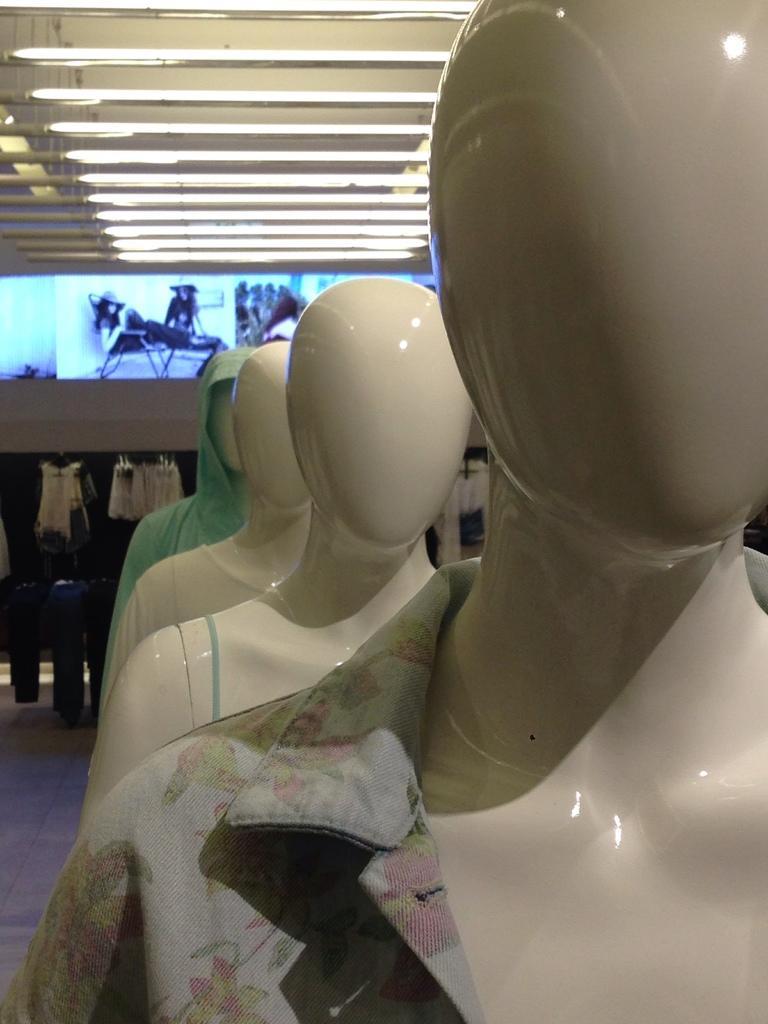In one or two sentences, can you explain what this image depicts? In this image there are mannequins. There are dresses on the mannequins. Behind the mannequins there are dressed to the hangers on the rods. In the background there is a wall. There are display screens on the wall. At the top there tube lights hanging to the ceiling. 